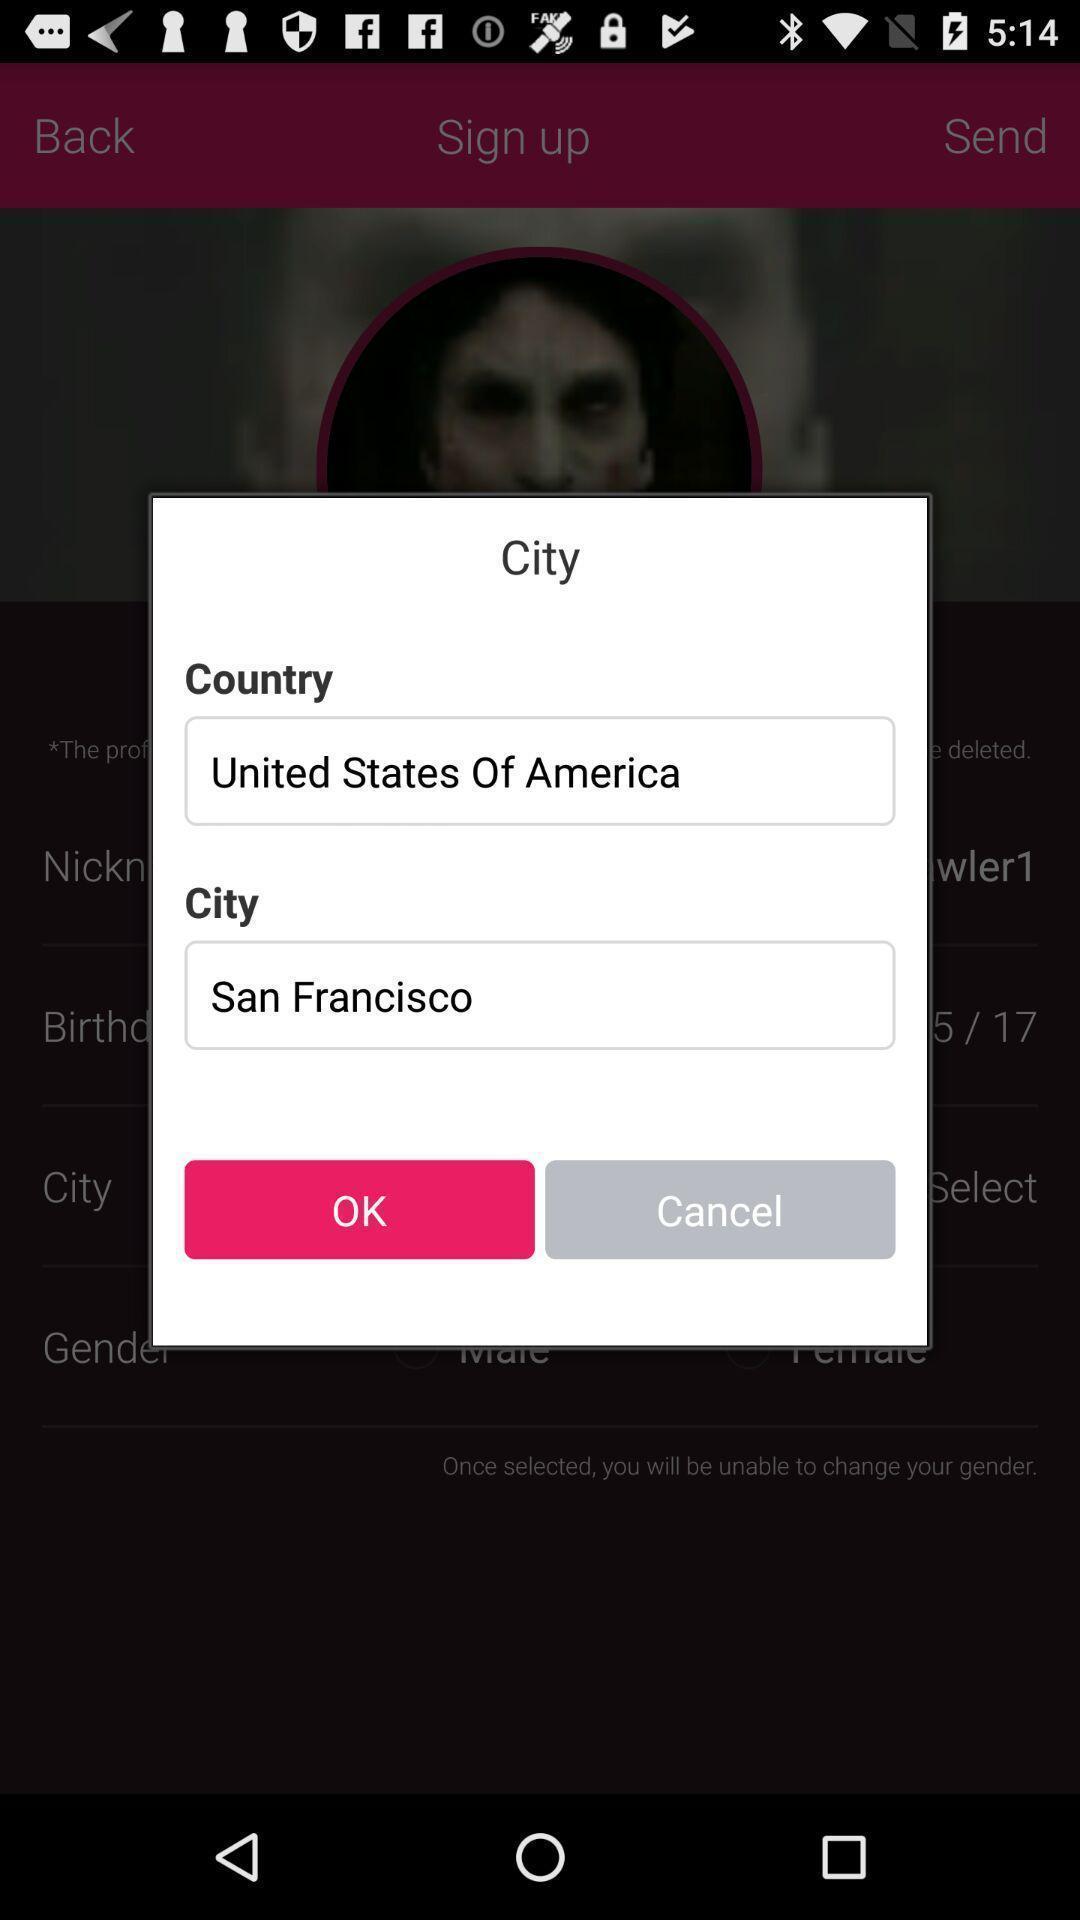Give me a summary of this screen capture. Pop-up to enter city details. 